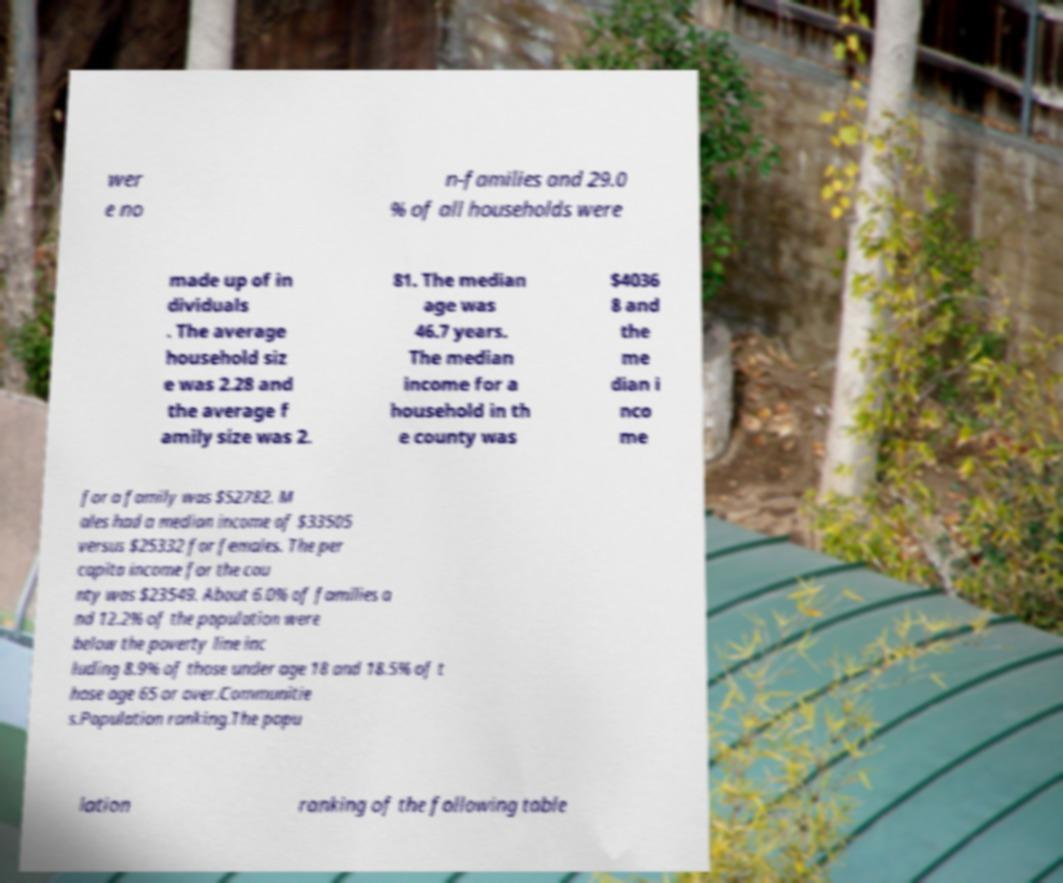What messages or text are displayed in this image? I need them in a readable, typed format. wer e no n-families and 29.0 % of all households were made up of in dividuals . The average household siz e was 2.28 and the average f amily size was 2. 81. The median age was 46.7 years. The median income for a household in th e county was $4036 8 and the me dian i nco me for a family was $52782. M ales had a median income of $33505 versus $25332 for females. The per capita income for the cou nty was $23549. About 6.0% of families a nd 12.2% of the population were below the poverty line inc luding 8.9% of those under age 18 and 18.5% of t hose age 65 or over.Communitie s.Population ranking.The popu lation ranking of the following table 